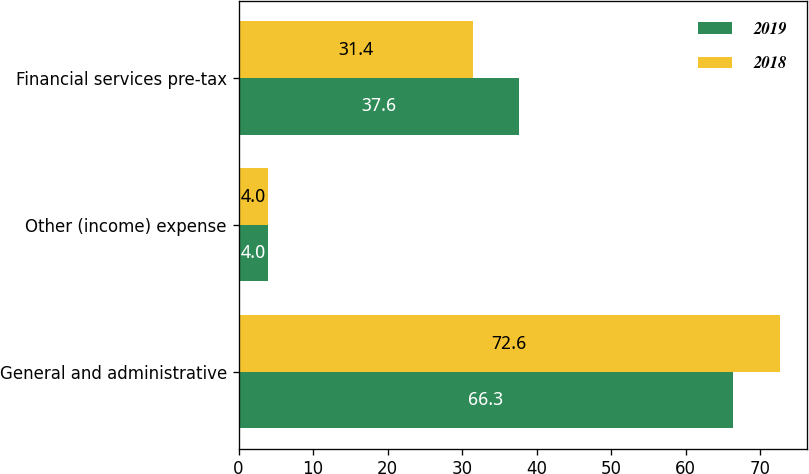Convert chart. <chart><loc_0><loc_0><loc_500><loc_500><stacked_bar_chart><ecel><fcel>General and administrative<fcel>Other (income) expense<fcel>Financial services pre-tax<nl><fcel>2019<fcel>66.3<fcel>4<fcel>37.6<nl><fcel>2018<fcel>72.6<fcel>4<fcel>31.4<nl></chart> 